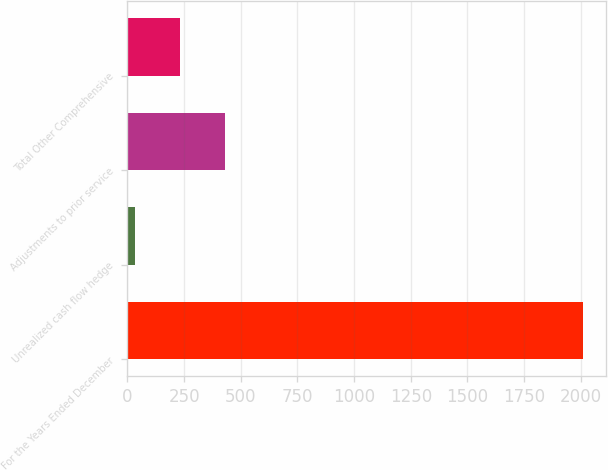Convert chart. <chart><loc_0><loc_0><loc_500><loc_500><bar_chart><fcel>For the Years Ended December<fcel>Unrealized cash flow hedge<fcel>Adjustments to prior service<fcel>Total Other Comprehensive<nl><fcel>2011<fcel>34.9<fcel>430.12<fcel>232.51<nl></chart> 